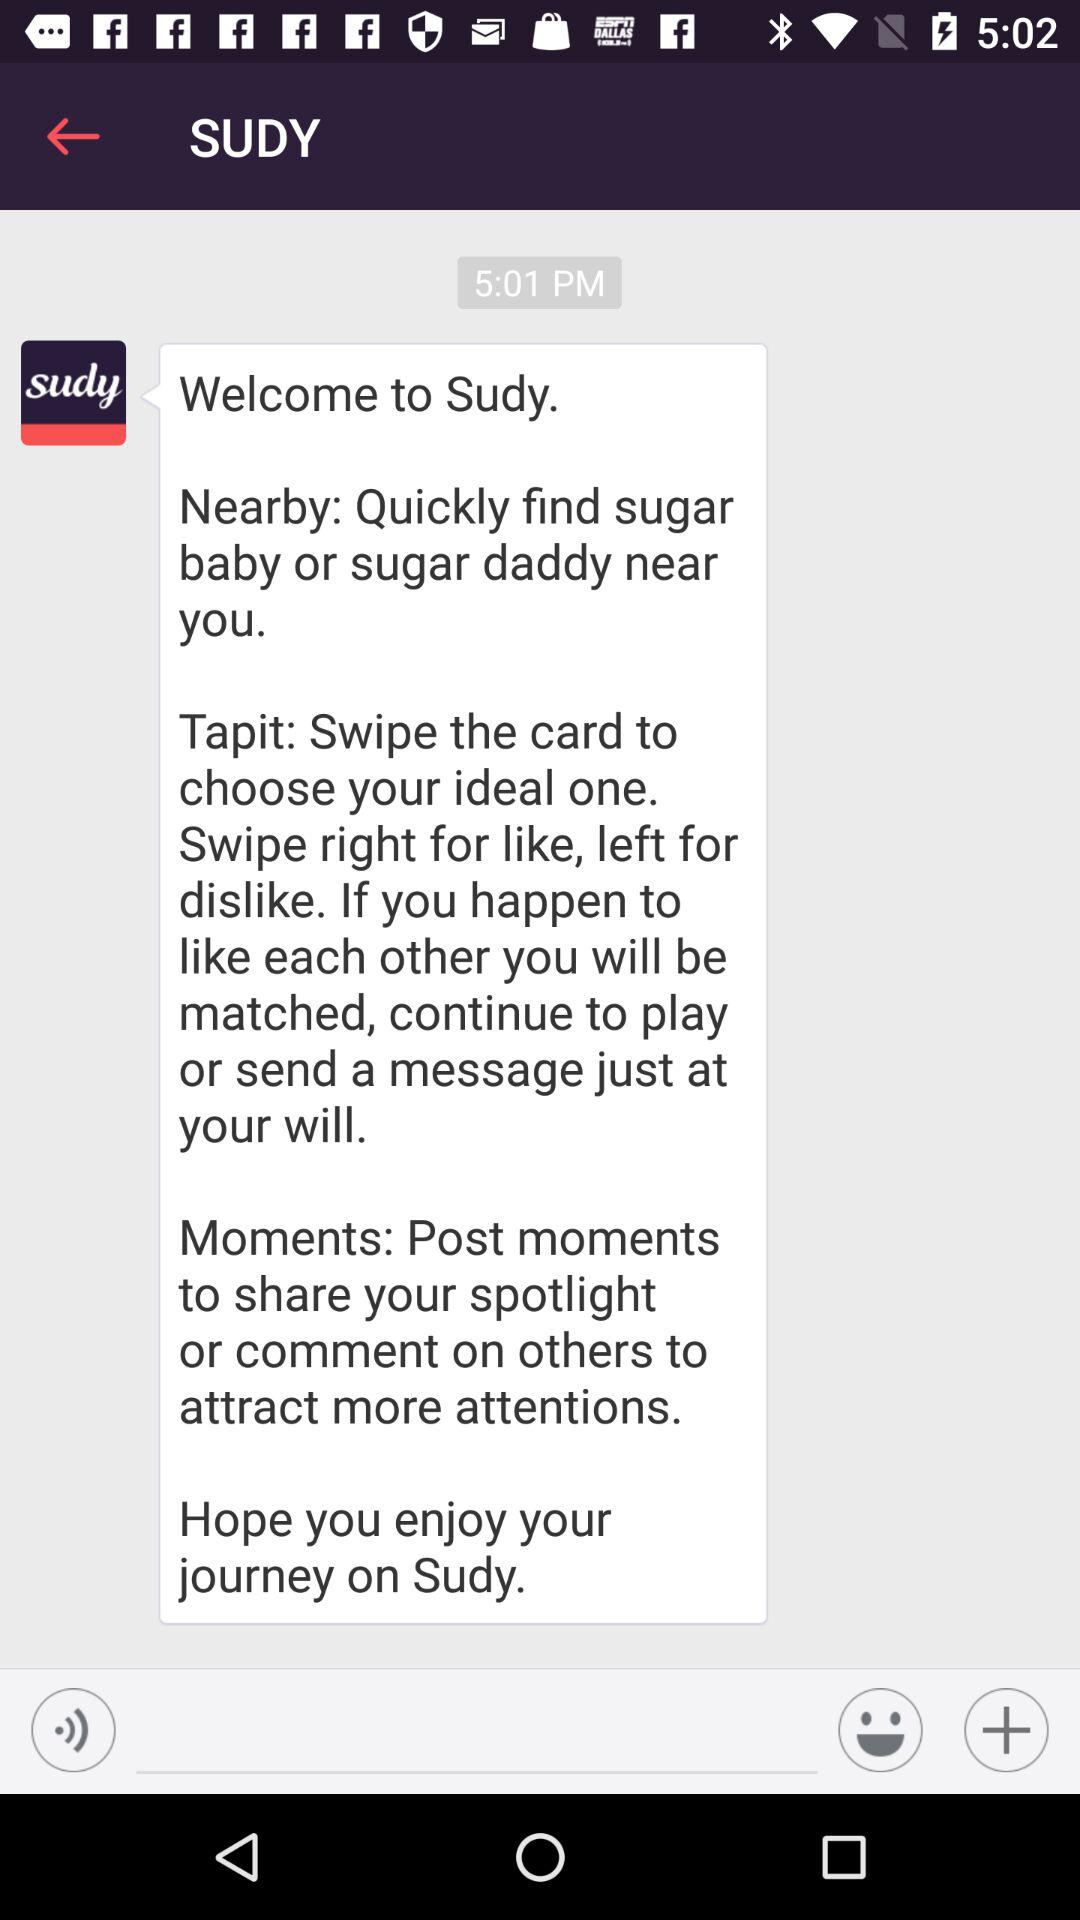What is the time of the message? The time of the message is 5:01 PM. 